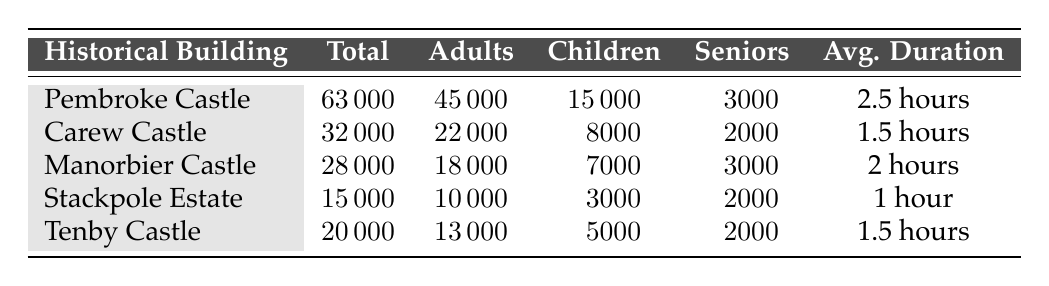What is the total number of visitors to Pembroke Castle? The table shows that the total number of visitors to Pembroke Castle is listed under the "Total" column. It states 63,000 visitors.
Answer: 63000 Which historical building had the least number of visitors? By comparing the total visitors for each historical building, Stackpole Estate has the lowest total of 15,000 visitors.
Answer: Stackpole Estate How many children visited Carew Castle? The number of children who visited Carew Castle can be found in the "Children" column for that building, which shows 8,000 children.
Answer: 8000 What is the average duration visitors spent at Manorbier Castle? The average duration for visitors at Manorbier Castle is indicated in the "Avg. Duration" column, which is 2 hours.
Answer: 2 hours What is the total number of adults who visited all historical buildings combined? To find the total number of adults, sum the values in the "Adults" column: 45,000 (Pembroke) + 22,000 (Carew) + 18,000 (Manorbier) + 10,000 (Stackpole) + 13,000 (Tenby) = 108,000 adults.
Answer: 108000 Did more seniors visit Pembroke Castle than Carew Castle? Pembroke Castle had 3,000 seniors while Carew Castle had 2,000 seniors. Since 3,000 is greater than 2,000, the statement is true.
Answer: Yes What percentage of the total visitors to Manorbier Castle were children? To calculate the percentage of children among the total visitors to Manorbier Castle: (7,000 children / 28,000 total visitors) × 100 = 25%.
Answer: 25% If we combine the total visitors of Tenby Castle and Stackpole Estate, what is that combined total? Adding Tenby Castle's 20,000 visitors and Stackpole Estate's 15,000 visitors gives a combined total of 35,000 visitors.
Answer: 35000 Which building had the highest number of children visitors? By examining the "Children" column, Pembroke Castle had the highest number of children visitors at 15,000.
Answer: Pembroke Castle How much longer, on average, do visitors spend at Pembroke Castle compared to Stackpole Estate? Pembroke Castle visitors spend an average of 2.5 hours, while Stackpole Estate visitors spend 1 hour. The difference is 2.5 hours - 1 hour = 1.5 hours.
Answer: 1.5 hours 